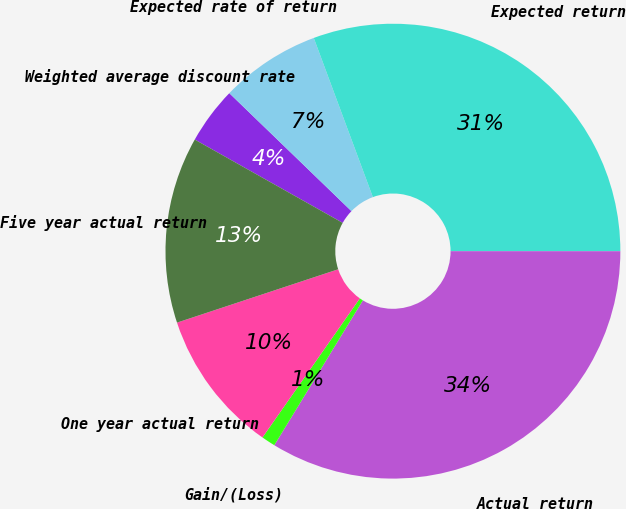<chart> <loc_0><loc_0><loc_500><loc_500><pie_chart><fcel>Weighted average discount rate<fcel>Expected rate of return<fcel>Expected return<fcel>Actual return<fcel>Gain/(Loss)<fcel>One year actual return<fcel>Five year actual return<nl><fcel>4.06%<fcel>7.12%<fcel>30.66%<fcel>33.73%<fcel>0.99%<fcel>10.19%<fcel>13.25%<nl></chart> 